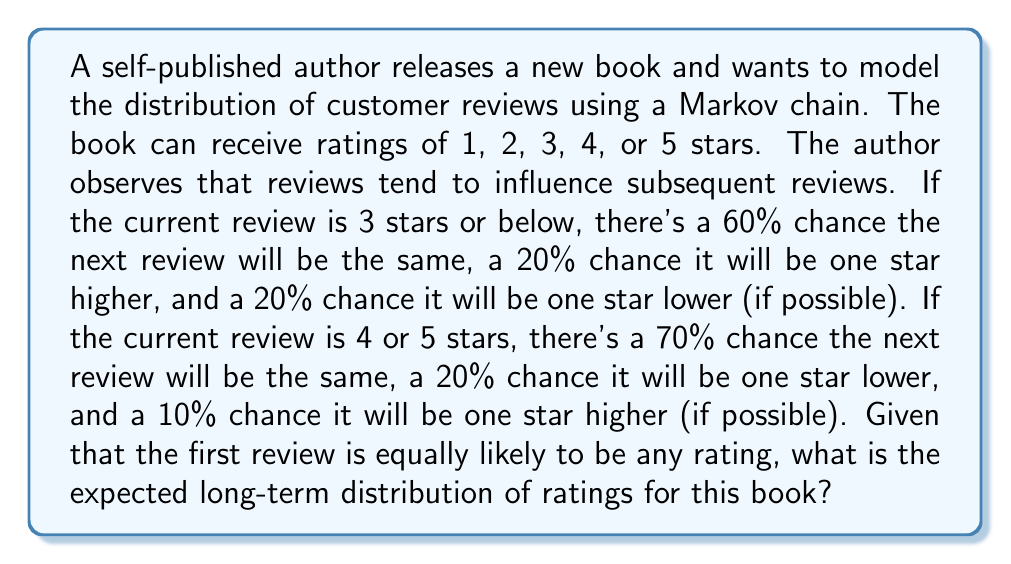Show me your answer to this math problem. Let's approach this step-by-step:

1) First, we need to set up the transition matrix P for our Markov chain. The states are the ratings 1, 2, 3, 4, and 5.

   $$P = \begin{bmatrix}
   0.6 & 0.2 & 0.2 & 0 & 0 \\
   0.2 & 0.6 & 0.2 & 0 & 0 \\
   0.2 & 0.2 & 0.6 & 0 & 0 \\
   0 & 0 & 0.2 & 0.7 & 0.1 \\
   0 & 0 & 0 & 0.2 & 0.7
   \end{bmatrix}$$

2) To find the long-term distribution, we need to solve the equation $\pi P = \pi$, where $\pi$ is the stationary distribution we're looking for.

3) Let $\pi = [\pi_1, \pi_2, \pi_3, \pi_4, \pi_5]$. We also know that $\sum_{i=1}^5 \pi_i = 1$.

4) Writing out the equations:

   $$\begin{align}
   0.6\pi_1 + 0.2\pi_2 + 0.2\pi_3 &= \pi_1 \\
   0.2\pi_1 + 0.6\pi_2 + 0.2\pi_3 &= \pi_2 \\
   0.2\pi_1 + 0.2\pi_2 + 0.6\pi_3 + 0.2\pi_4 &= \pi_3 \\
   0.2\pi_3 + 0.7\pi_4 + 0.2\pi_5 &= \pi_4 \\
   0.1\pi_4 + 0.7\pi_5 &= \pi_5 \\
   \pi_1 + \pi_2 + \pi_3 + \pi_4 + \pi_5 &= 1
   \end{align}$$

5) Solving this system of equations (using a computer algebra system or numerical methods), we get:

   $$\pi \approx [0.1667, 0.1667, 0.1667, 0.2500, 0.2500]$$

6) This means that in the long run:
   - 1-star, 2-star, and 3-star ratings each occur about 16.67% of the time
   - 4-star and 5-star ratings each occur about 25% of the time
Answer: $[0.1667, 0.1667, 0.1667, 0.2500, 0.2500]$ 